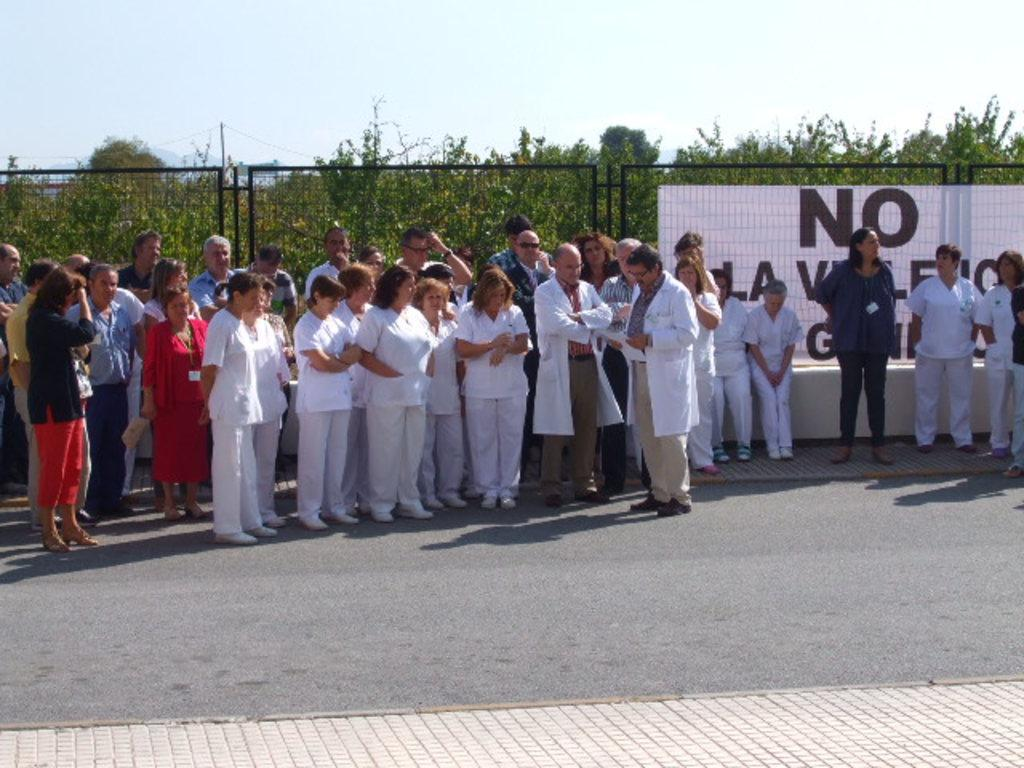Who or what can be seen in the image? There are people in the image. What is hanging or displayed in the image? There is a banner in the image. What type of barrier is present in the image? There is a fence in the image. What type of vegetation is visible in the image? There are trees in the image. What is visible in the background of the image? The sky is visible in the image. How many balls are being juggled by the people in the image? There are no balls visible in the image, and the people are not shown juggling anything. 